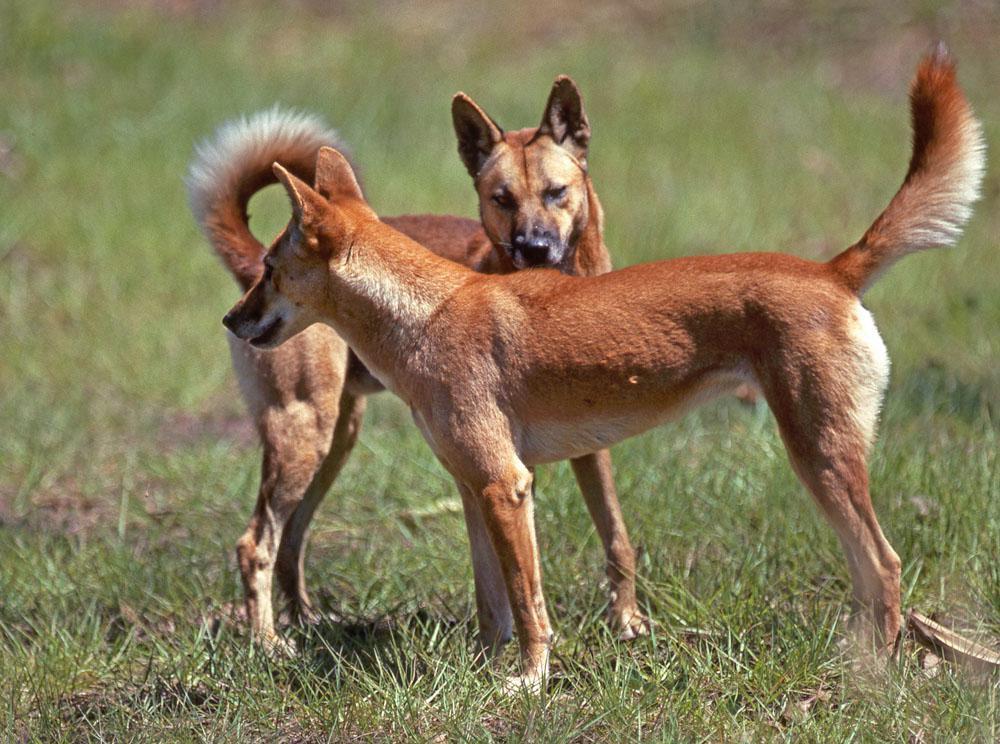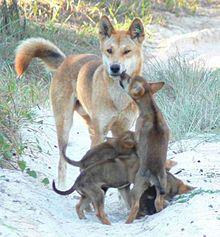The first image is the image on the left, the second image is the image on the right. Assess this claim about the two images: "There are more dogs in the right image than in the left.". Correct or not? Answer yes or no. Yes. The first image is the image on the left, the second image is the image on the right. Evaluate the accuracy of this statement regarding the images: "One animal is standing in the image on the left.". Is it true? Answer yes or no. No. 